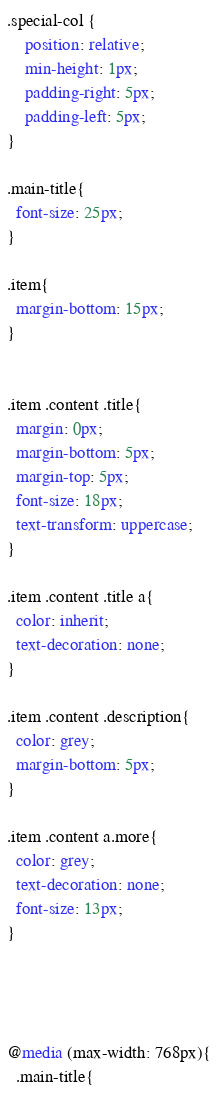<code> <loc_0><loc_0><loc_500><loc_500><_CSS_>.special-col {
    position: relative;
    min-height: 1px;
    padding-right: 5px;
    padding-left: 5px;
}

.main-title{
  font-size: 25px;
}

.item{
  margin-bottom: 15px;
}


.item .content .title{
  margin: 0px;
  margin-bottom: 5px;
  margin-top: 5px;
  font-size: 18px;
  text-transform: uppercase;
}

.item .content .title a{
  color: inherit;
  text-decoration: none;
}

.item .content .description{
  color: grey;
  margin-bottom: 5px;
}

.item .content a.more{
  color: grey;
  text-decoration: none;
  font-size: 13px;
}




@media (max-width: 768px){
  .main-title{</code> 